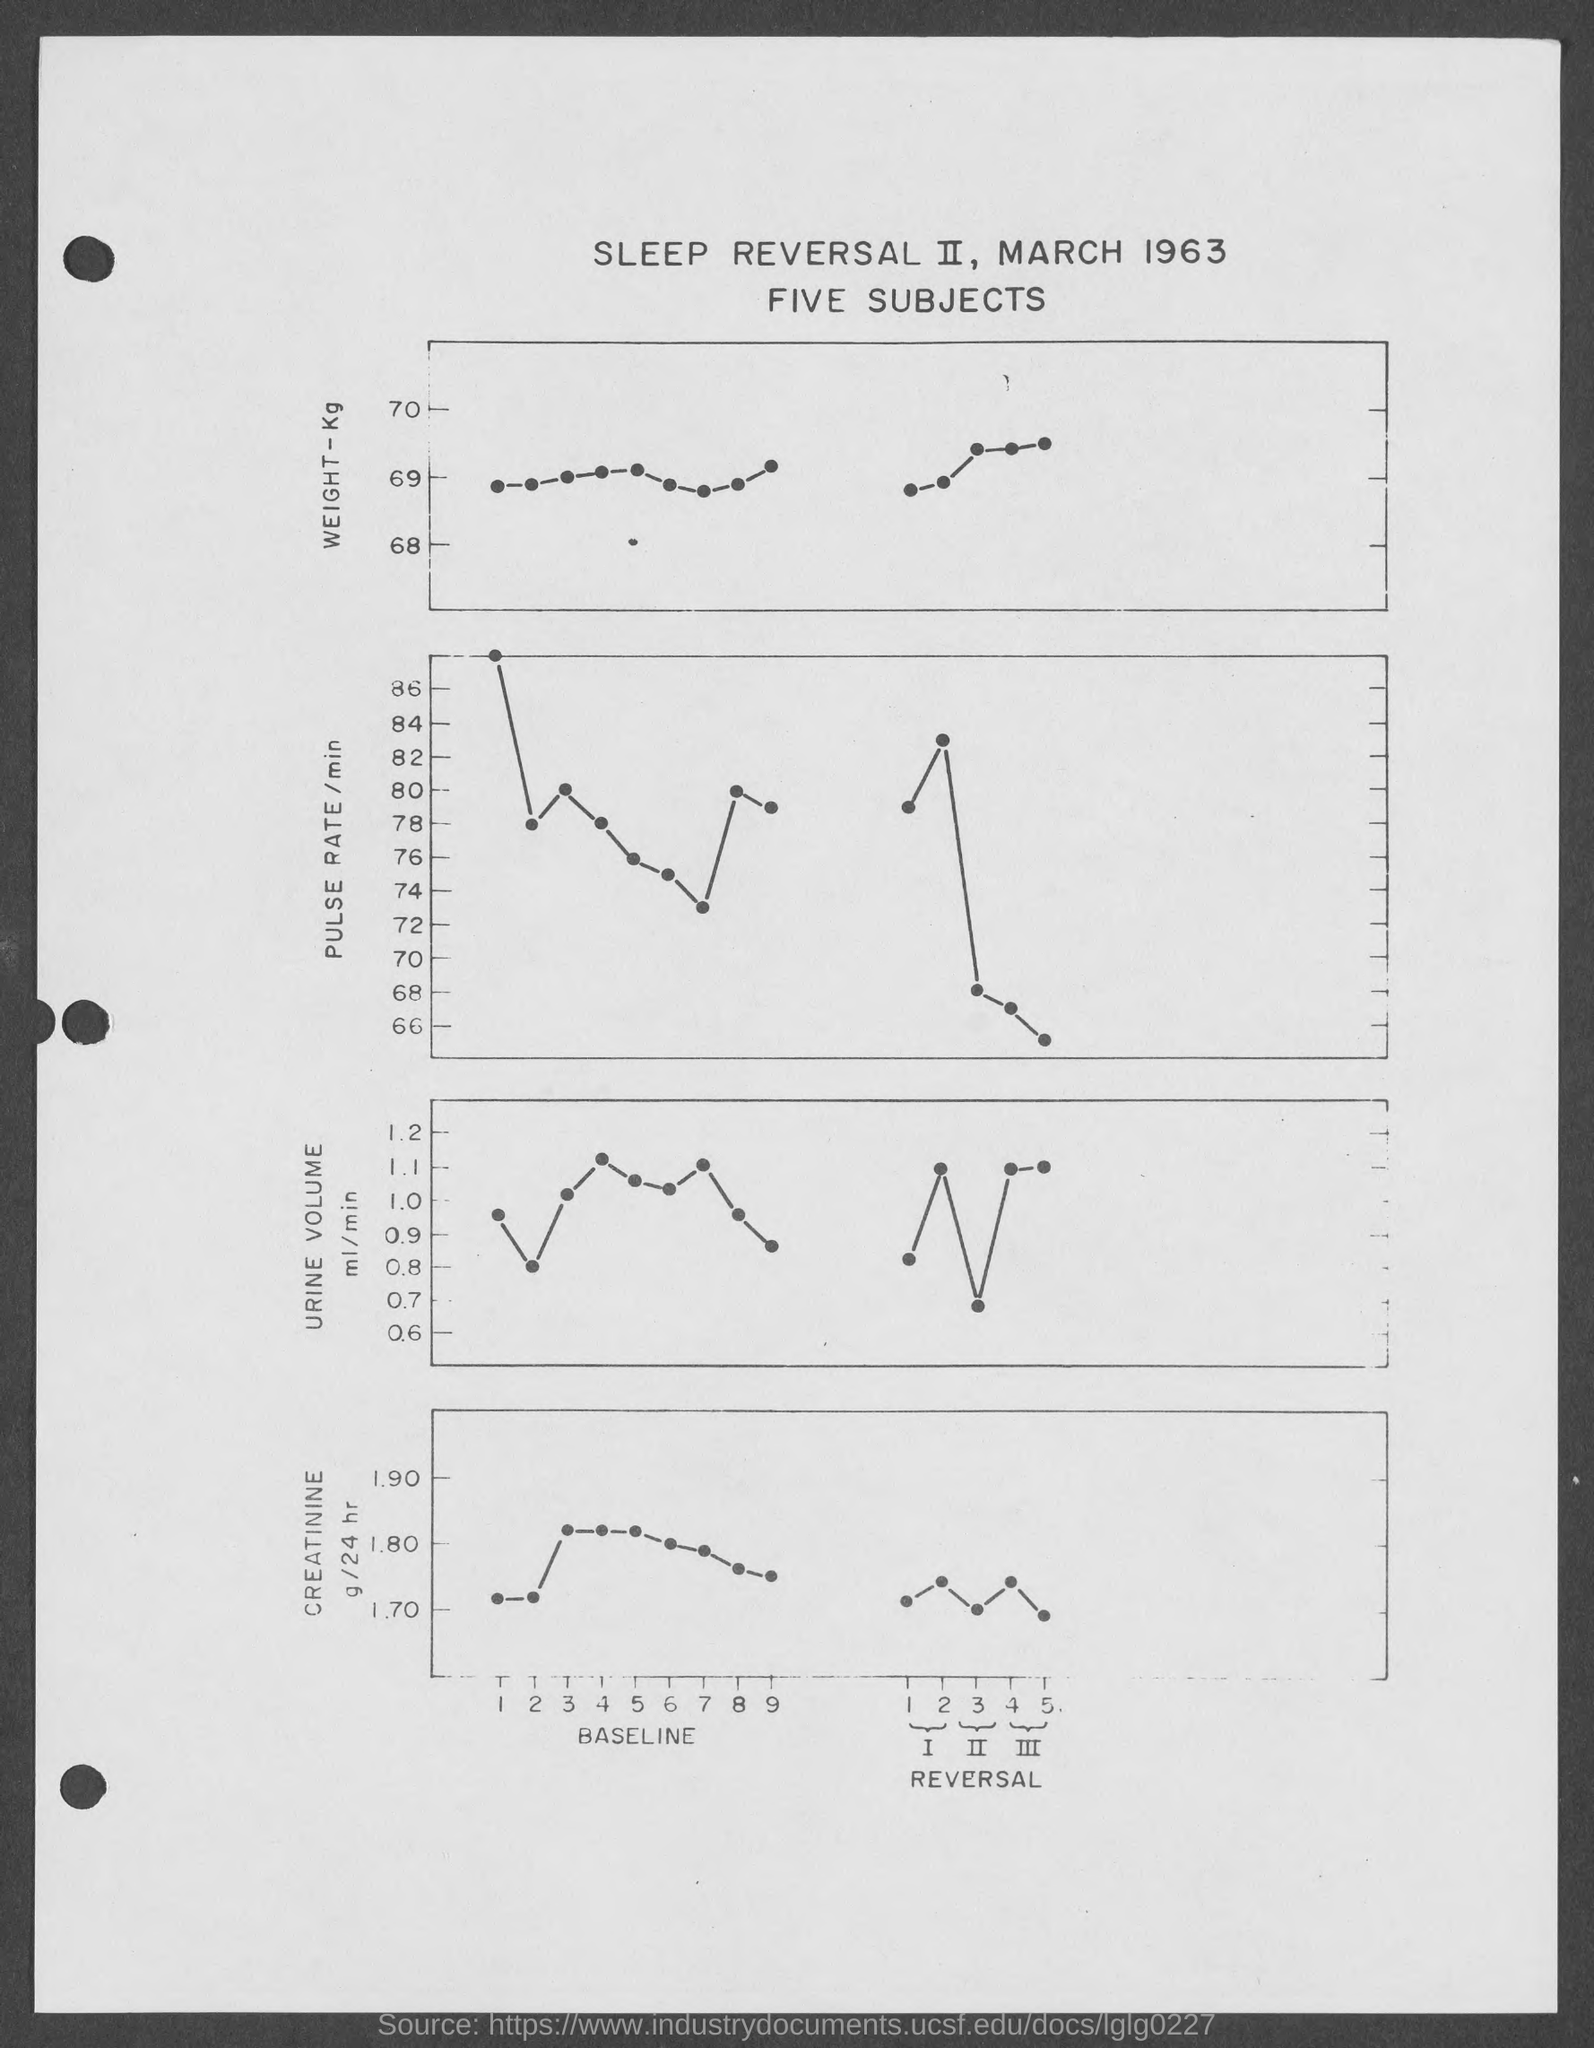What is the date mentioned in the given page ?
Offer a very short reply. March 1963. 